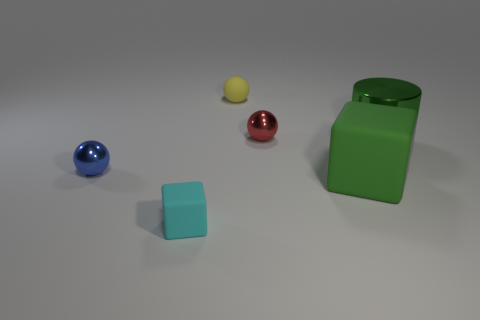How many tiny objects are cyan objects or purple cylinders?
Ensure brevity in your answer.  1. Are there more cyan cubes than things?
Give a very brief answer. No. Is the material of the red ball the same as the cyan thing?
Offer a terse response. No. Is there anything else that has the same material as the large green cube?
Your answer should be very brief. Yes. Are there more large green things that are left of the large cylinder than tiny gray metal objects?
Your response must be concise. Yes. Does the big cylinder have the same color as the large rubber cube?
Ensure brevity in your answer.  Yes. What number of green objects are the same shape as the small cyan matte thing?
Your response must be concise. 1. There is a green thing that is the same material as the small blue thing; what is its size?
Your response must be concise. Large. The thing that is right of the rubber ball and left of the big matte cube is what color?
Your answer should be very brief. Red. How many green things are the same size as the cylinder?
Your answer should be compact. 1. 